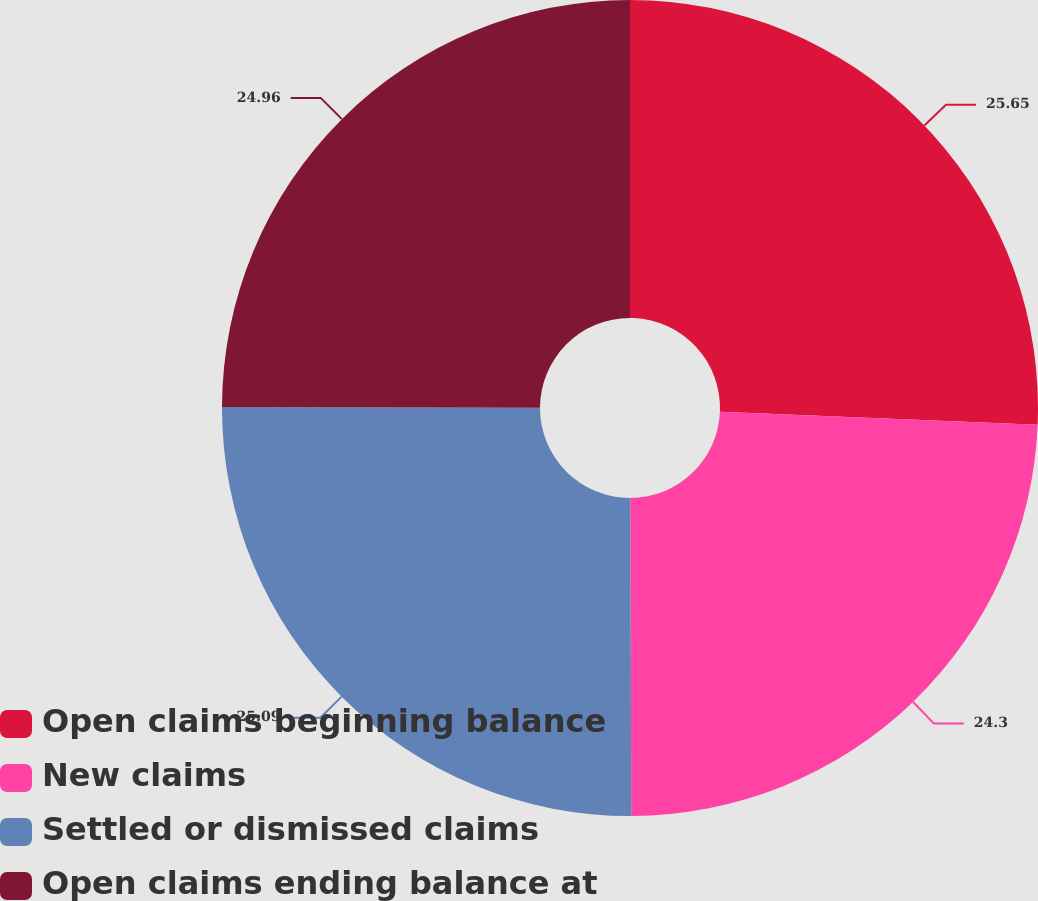Convert chart to OTSL. <chart><loc_0><loc_0><loc_500><loc_500><pie_chart><fcel>Open claims beginning balance<fcel>New claims<fcel>Settled or dismissed claims<fcel>Open claims ending balance at<nl><fcel>25.65%<fcel>24.3%<fcel>25.09%<fcel>24.96%<nl></chart> 